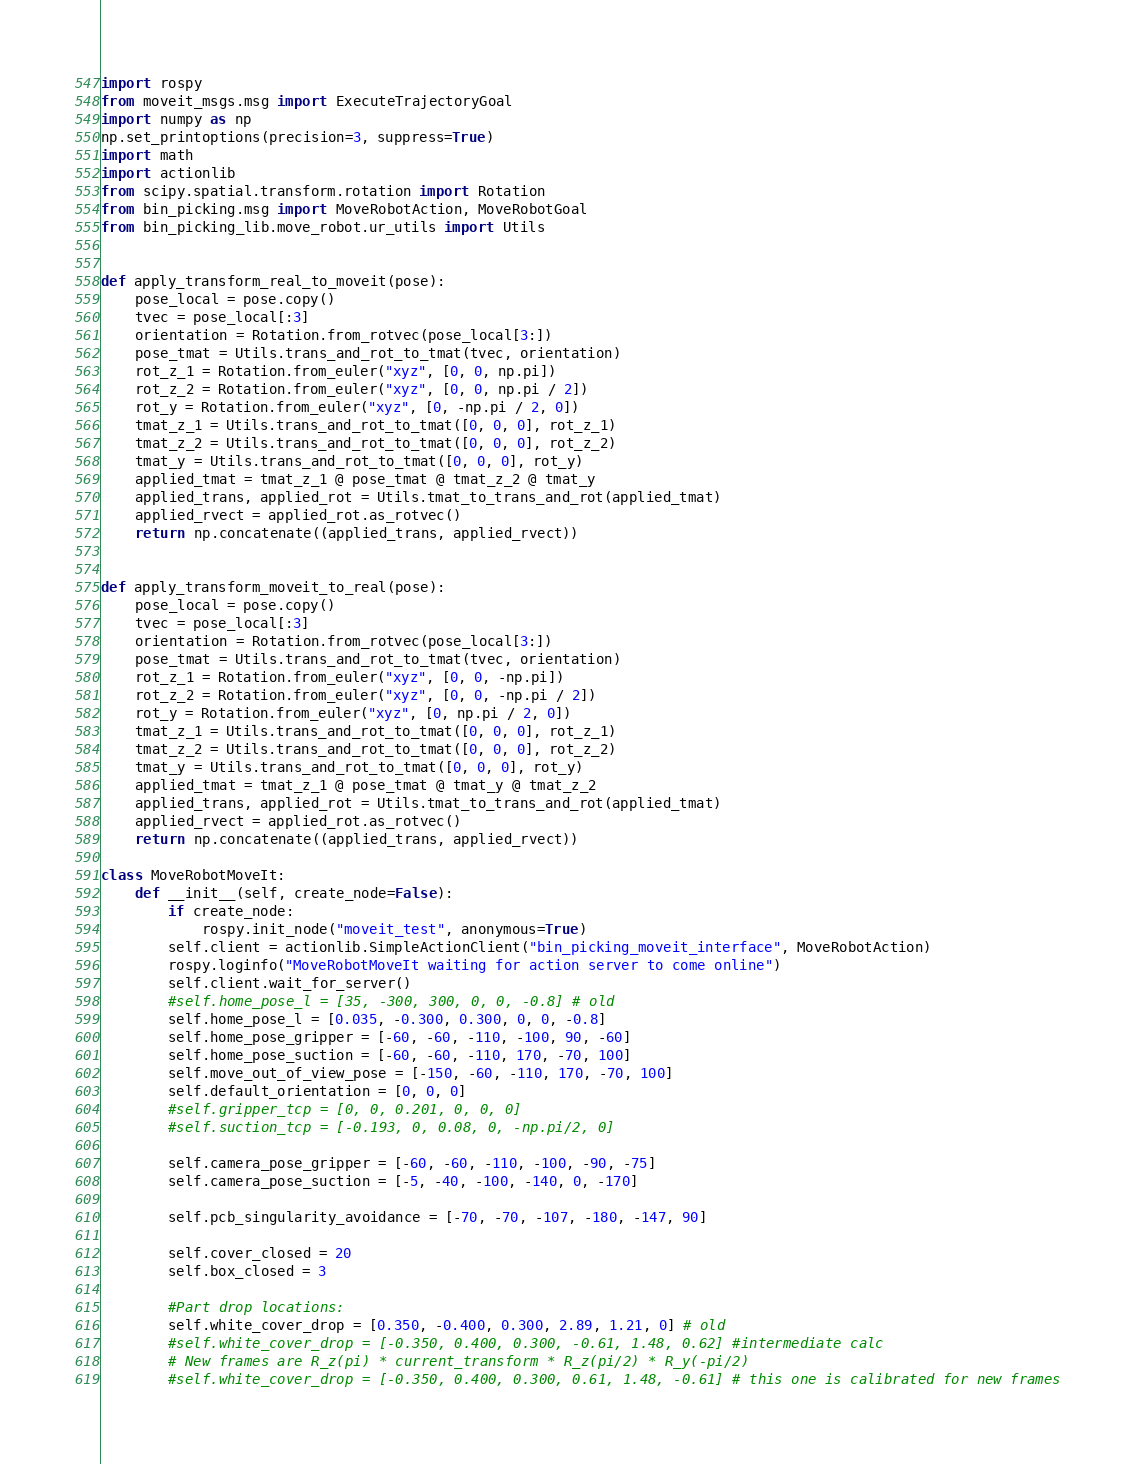<code> <loc_0><loc_0><loc_500><loc_500><_Python_>import rospy
from moveit_msgs.msg import ExecuteTrajectoryGoal
import numpy as np
np.set_printoptions(precision=3, suppress=True)
import math
import actionlib
from scipy.spatial.transform.rotation import Rotation
from bin_picking.msg import MoveRobotAction, MoveRobotGoal
from bin_picking_lib.move_robot.ur_utils import Utils


def apply_transform_real_to_moveit(pose):
    pose_local = pose.copy()
    tvec = pose_local[:3]
    orientation = Rotation.from_rotvec(pose_local[3:])
    pose_tmat = Utils.trans_and_rot_to_tmat(tvec, orientation)
    rot_z_1 = Rotation.from_euler("xyz", [0, 0, np.pi])
    rot_z_2 = Rotation.from_euler("xyz", [0, 0, np.pi / 2])
    rot_y = Rotation.from_euler("xyz", [0, -np.pi / 2, 0])
    tmat_z_1 = Utils.trans_and_rot_to_tmat([0, 0, 0], rot_z_1)
    tmat_z_2 = Utils.trans_and_rot_to_tmat([0, 0, 0], rot_z_2)
    tmat_y = Utils.trans_and_rot_to_tmat([0, 0, 0], rot_y)
    applied_tmat = tmat_z_1 @ pose_tmat @ tmat_z_2 @ tmat_y
    applied_trans, applied_rot = Utils.tmat_to_trans_and_rot(applied_tmat)
    applied_rvect = applied_rot.as_rotvec()
    return np.concatenate((applied_trans, applied_rvect))


def apply_transform_moveit_to_real(pose):
    pose_local = pose.copy()
    tvec = pose_local[:3]
    orientation = Rotation.from_rotvec(pose_local[3:])
    pose_tmat = Utils.trans_and_rot_to_tmat(tvec, orientation)
    rot_z_1 = Rotation.from_euler("xyz", [0, 0, -np.pi])
    rot_z_2 = Rotation.from_euler("xyz", [0, 0, -np.pi / 2])
    rot_y = Rotation.from_euler("xyz", [0, np.pi / 2, 0])
    tmat_z_1 = Utils.trans_and_rot_to_tmat([0, 0, 0], rot_z_1)
    tmat_z_2 = Utils.trans_and_rot_to_tmat([0, 0, 0], rot_z_2)
    tmat_y = Utils.trans_and_rot_to_tmat([0, 0, 0], rot_y)
    applied_tmat = tmat_z_1 @ pose_tmat @ tmat_y @ tmat_z_2
    applied_trans, applied_rot = Utils.tmat_to_trans_and_rot(applied_tmat)
    applied_rvect = applied_rot.as_rotvec()
    return np.concatenate((applied_trans, applied_rvect))

class MoveRobotMoveIt:
    def __init__(self, create_node=False):
        if create_node:
            rospy.init_node("moveit_test", anonymous=True)
        self.client = actionlib.SimpleActionClient("bin_picking_moveit_interface", MoveRobotAction)
        rospy.loginfo("MoveRobotMoveIt waiting for action server to come online")
        self.client.wait_for_server()
        #self.home_pose_l = [35, -300, 300, 0, 0, -0.8] # old
        self.home_pose_l = [0.035, -0.300, 0.300, 0, 0, -0.8]
        self.home_pose_gripper = [-60, -60, -110, -100, 90, -60]
        self.home_pose_suction = [-60, -60, -110, 170, -70, 100]
        self.move_out_of_view_pose = [-150, -60, -110, 170, -70, 100]
        self.default_orientation = [0, 0, 0]
        #self.gripper_tcp = [0, 0, 0.201, 0, 0, 0]
        #self.suction_tcp = [-0.193, 0, 0.08, 0, -np.pi/2, 0]

        self.camera_pose_gripper = [-60, -60, -110, -100, -90, -75]
        self.camera_pose_suction = [-5, -40, -100, -140, 0, -170]

        self.pcb_singularity_avoidance = [-70, -70, -107, -180, -147, 90]

        self.cover_closed = 20
        self.box_closed = 3

        #Part drop locations:
        self.white_cover_drop = [0.350, -0.400, 0.300, 2.89, 1.21, 0] # old
        #self.white_cover_drop = [-0.350, 0.400, 0.300, -0.61, 1.48, 0.62] #intermediate calc
        # New frames are R_z(pi) * current_transform * R_z(pi/2) * R_y(-pi/2)
        #self.white_cover_drop = [-0.350, 0.400, 0.300, 0.61, 1.48, -0.61] # this one is calibrated for new frames</code> 